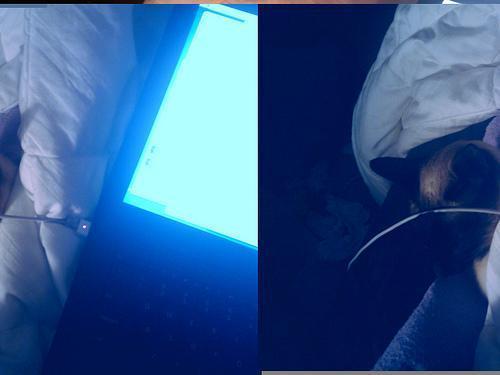How many cats are pictured?
Give a very brief answer. 1. 